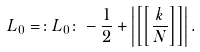Convert formula to latex. <formula><loc_0><loc_0><loc_500><loc_500>L _ { 0 } = \colon L _ { 0 } \colon - \frac { 1 } { 2 } + \left | \left [ \left [ \frac { k } { N } \right ] \right ] \right | .</formula> 